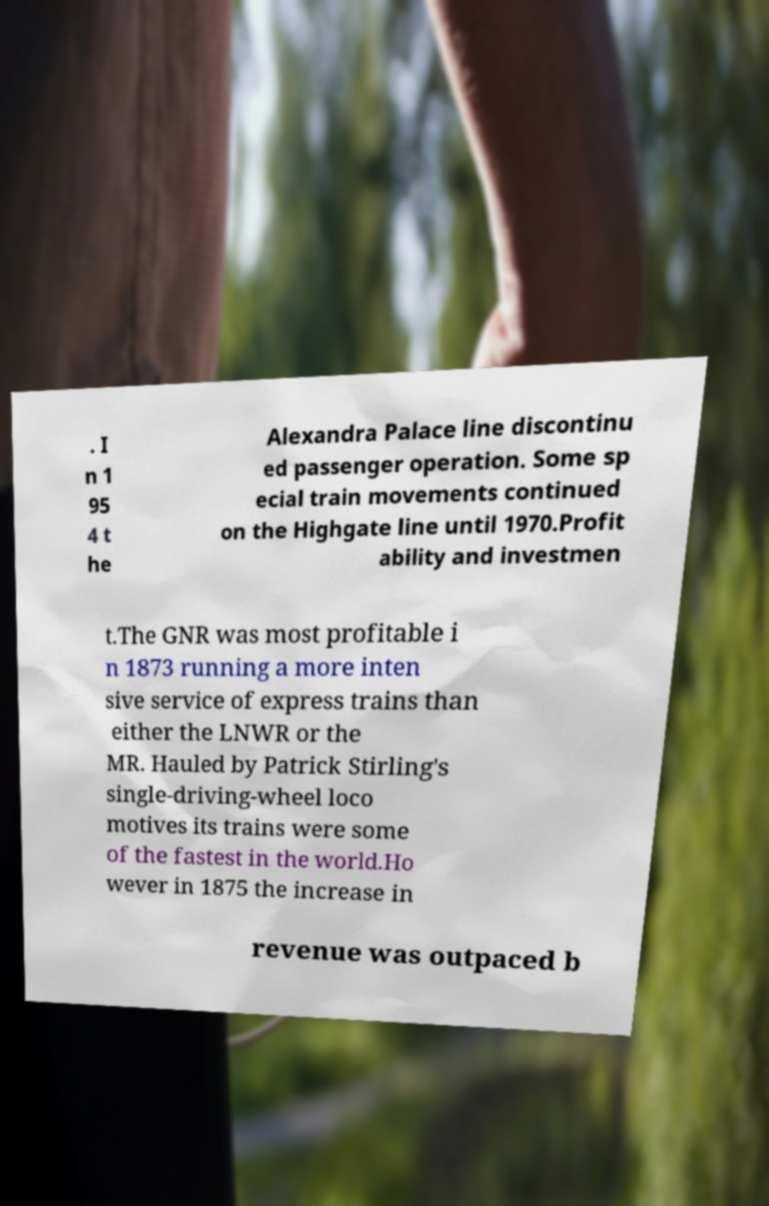Can you read and provide the text displayed in the image?This photo seems to have some interesting text. Can you extract and type it out for me? . I n 1 95 4 t he Alexandra Palace line discontinu ed passenger operation. Some sp ecial train movements continued on the Highgate line until 1970.Profit ability and investmen t.The GNR was most profitable i n 1873 running a more inten sive service of express trains than either the LNWR or the MR. Hauled by Patrick Stirling's single-driving-wheel loco motives its trains were some of the fastest in the world.Ho wever in 1875 the increase in revenue was outpaced b 